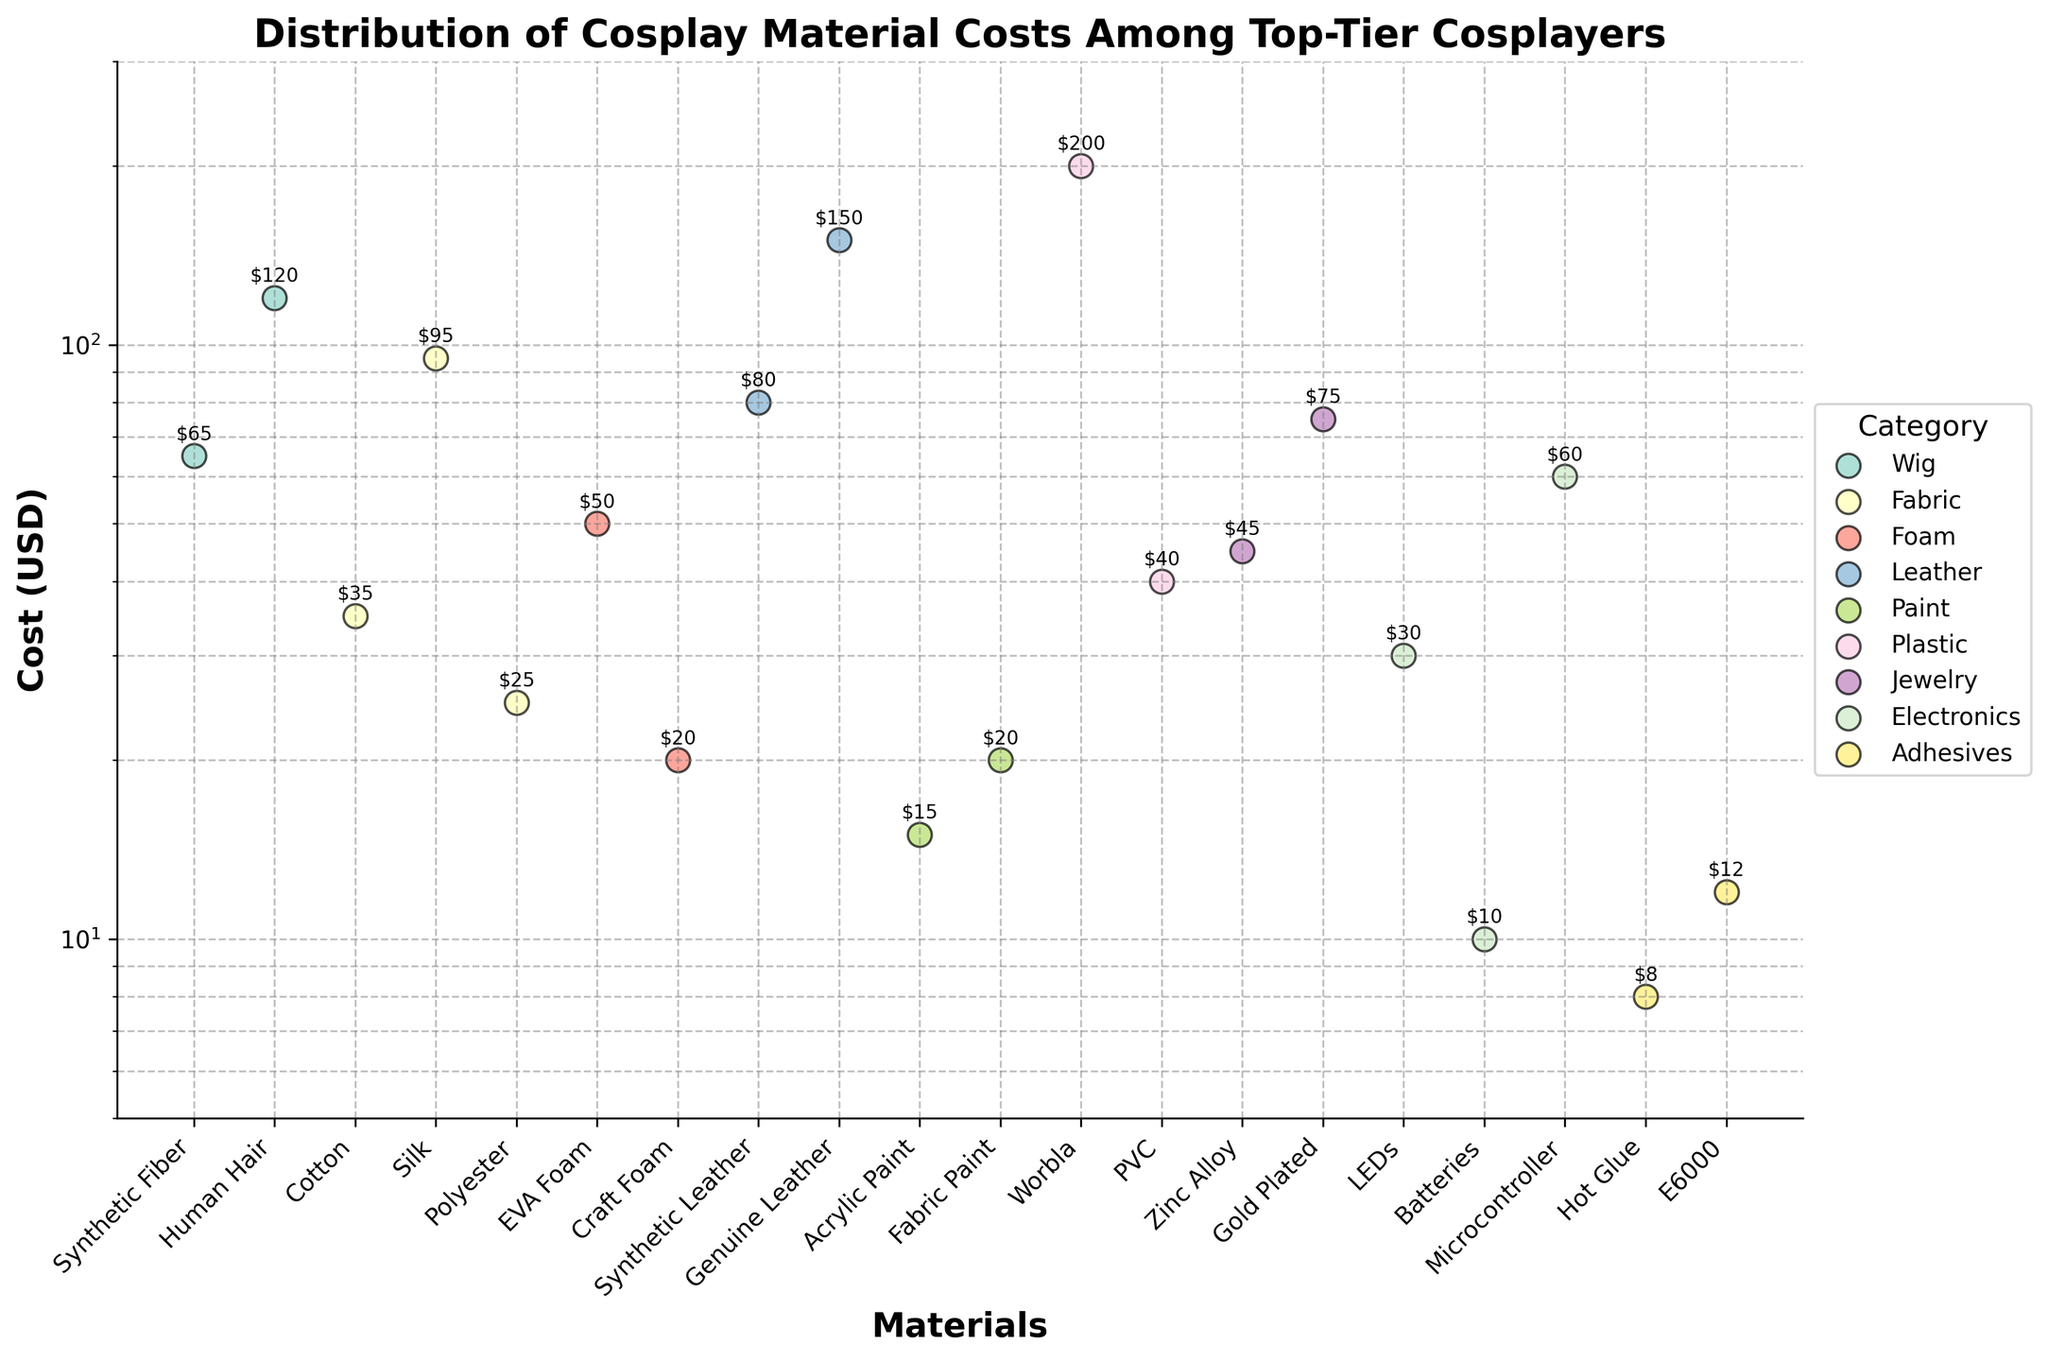What is the title of the figure? The title is prominently displayed at the top of the figure, reading "Distribution of Cosplay Material Costs Among Top-Tier Cosplayers."
Answer: Distribution of Cosplay Material Costs Among Top-Tier Cosplayers How is the y-axis scaled, and what are its limits? The y-axis is scaled logarithmically, which is evident from the evenly spaced multiplicative steps. The limits of the y-axis are from 5 to 300 USD.
Answer: Logarithmically scaled, 5 to 300 USD Which category has the highest individual material cost, and what is the cost? By examining the scatter plot, the highest cost is 200 USD, associated with the Plastic category for the material Worbla.
Answer: Plastic, 200 USD How many categories are represented in the figure? Each distinct color in the scatter plot represents a unique category. Counting the different colors and corresponding legend items, there are 9 categories.
Answer: 9 categories What is the cost range for materials in the Fabric category? By looking at the scatter points labeled "Fabric," the lowest cost is for Polyester at 25 USD, and the highest cost is Silk at 95 USD.
Answer: 25 to 95 USD Which material in the Electronics category has the highest cost, and what is it? Among the points labeled Electronics, the material with the highest cost is Microcontroller, at 60 USD.
Answer: Microcontroller, 60 USD Compare the costs of Synthetic Fiber wig and Human Hair wig. Which one is more expensive and by how much? The cost for Synthetic Fiber wig is 65 USD, and the cost for Human Hair wig is 120 USD. The Human Hair wig is more expensive by the difference of 120 - 65 = 55 USD.
Answer: Human Hair wig, 55 USD Which material cost is closest to the lower limit of the y-axis, and what is its cost? The material closest to the lower limit of 5 USD is Hot Glue under the Adhesives category, costing 8 USD.
Answer: Hot Glue, 8 USD How do costs for items in the Jewelry category compare to each other? The Jewelry category has Zinc Alloy at 45 USD and Gold Plated at 75 USD. Gold Plated is more expensive by 75 - 45 = 30 USD.
Answer: Gold Plated is more expensive by 30 USD 